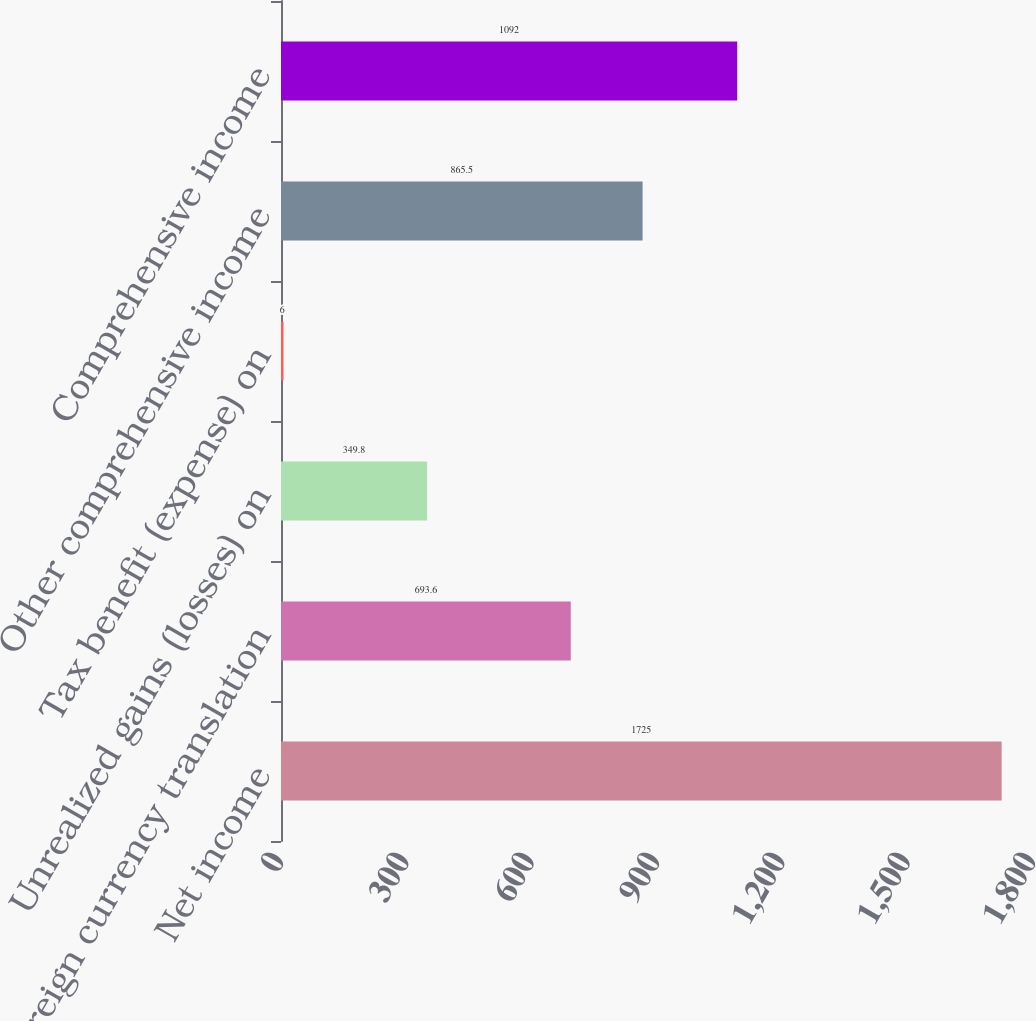<chart> <loc_0><loc_0><loc_500><loc_500><bar_chart><fcel>Net income<fcel>Foreign currency translation<fcel>Unrealized gains (losses) on<fcel>Tax benefit (expense) on<fcel>Other comprehensive income<fcel>Comprehensive income<nl><fcel>1725<fcel>693.6<fcel>349.8<fcel>6<fcel>865.5<fcel>1092<nl></chart> 